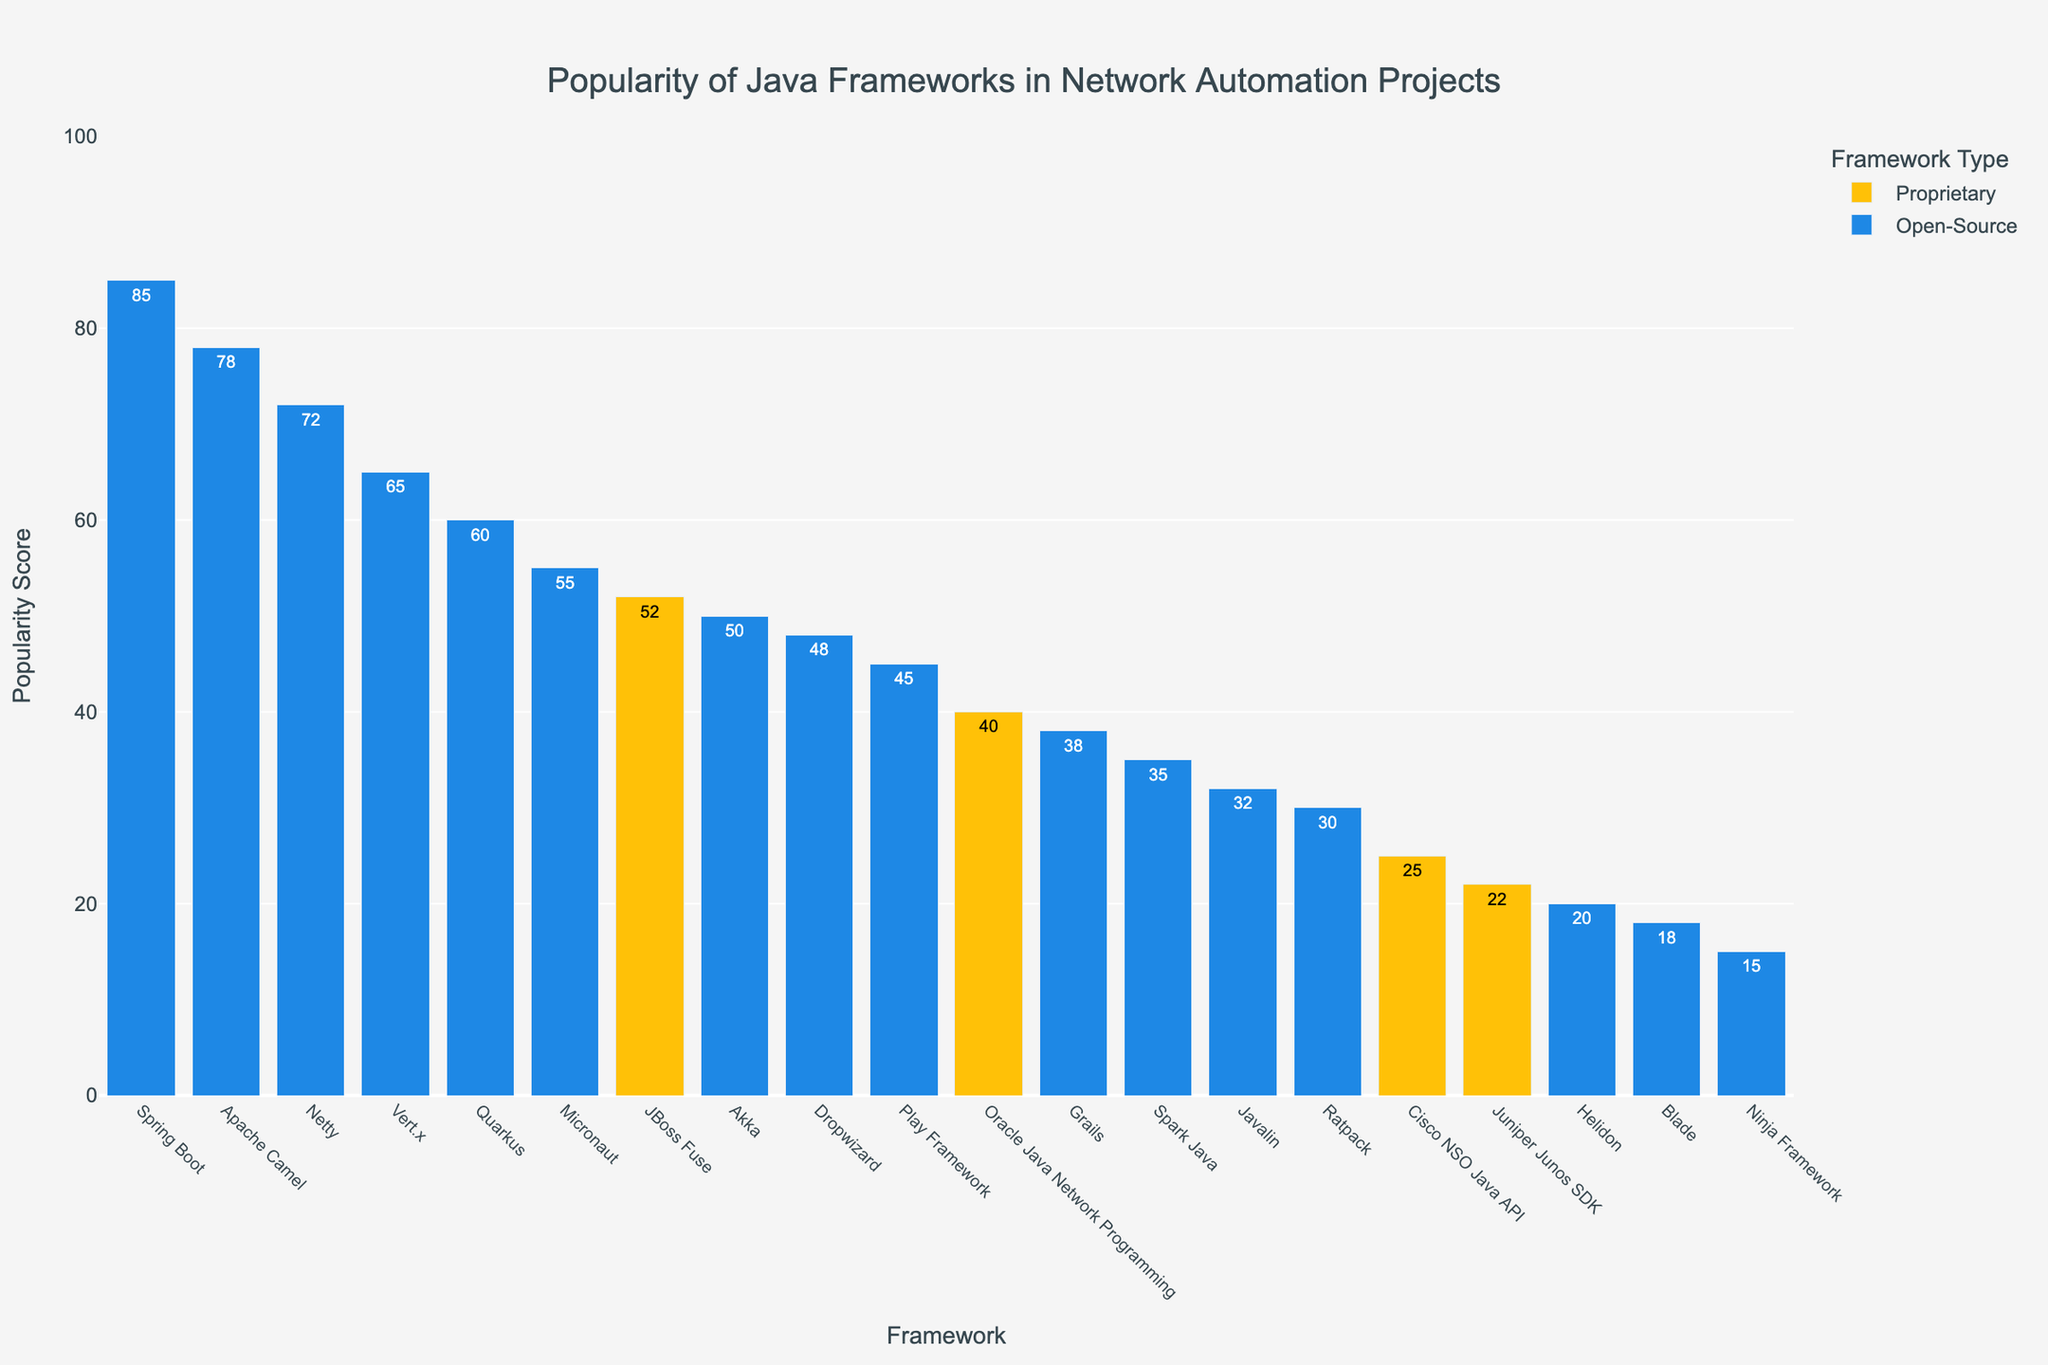Which Java framework has the highest popularity score? The figure shows popularity scores for various Java frameworks, and the framework with the largest bar is the one with the highest score. In this case, it is Spring Boot with a popularity score of 92.
Answer: Spring Boot How many proprietary frameworks are listed? By examining the bars colored differently for proprietary (yellow), we can count them. The proprietary frameworks are JBoss Fuse, Oracle Java Network Programming, Cisco NSO Java API, and Juniper Junos SDK.
Answer: 4 What is the difference in popularity scores between the most popular open-source framework and the most popular proprietary framework? The most popular open-source framework is Spring Boot with a score of 92, and the most popular proprietary framework is JBoss Fuse with a score of 48. The difference is calculated as 92 - 48.
Answer: 44 Which framework ranks third in popularity overall and what is its score? By examining the sorted order of the bars, the third highest overall popularity is for Netty with a score of 68.
Answer: Netty, 68 What is the combined popularity score of all open-source frameworks? Add the popularity scores of all frameworks listed under the Open-Source category: 92 + 75 + 68 + 60 + 55 + 50 + 45 + 42 + 40 + 35 + 32 + 30 + 28 + 20 + 18 + 15.
Answer: 705 Which proprietary framework has the lowest popularity score? Among the proprietary frameworks (yellow bars), Juniper Junos SDK has the lowest score of 22.
Answer: Juniper Junos SDK How many frameworks have a popularity score above 50? Count the frameworks with popularity scores greater than 50. They are Spring Boot, Apache Camel, Netty, Vert.x, Quarkus, and Micronaut.
Answer: 6 Between JBoss Fuse and Apache Camel, which framework has a higher popularity score and by how much? JBoss Fuse has a score of 48, and Apache Camel has a score of 75. The difference in scores is 75 - 48.
Answer: Apache Camel, 27 What is the median popularity score of all frameworks? To find the median, list order the popularity scores. With 19 frameworks, the middle is the 10th score in the list: 92, 75, 68, 60, 55, 50, 48, 45, 42, (40), 38, 35, 32, 30, 28, 25, 22, 20, 18, 15. The median score is 40.
Answer: 40 Which open-source framework has the least popularity score and what is it? Among the open-source frameworks (blue bars), Ninja Framework has the least score of 15.
Answer: Ninja Framework, 15 